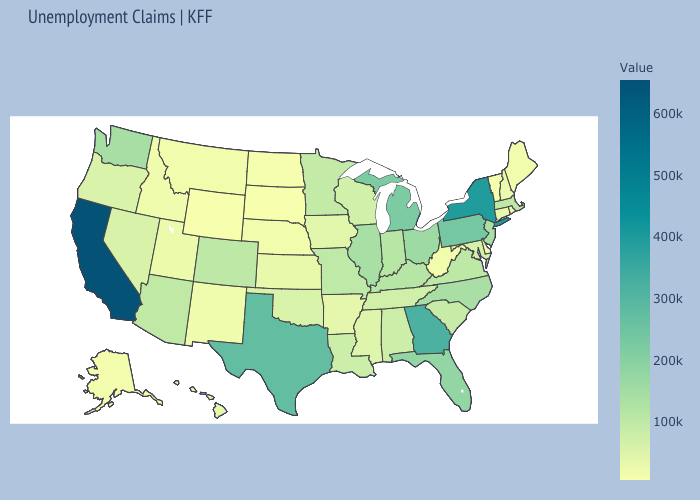Which states have the lowest value in the Northeast?
Quick response, please. Vermont. Among the states that border Virginia , which have the highest value?
Quick response, please. North Carolina. Among the states that border Nebraska , does Missouri have the lowest value?
Keep it brief. No. Which states have the lowest value in the Northeast?
Write a very short answer. Vermont. 